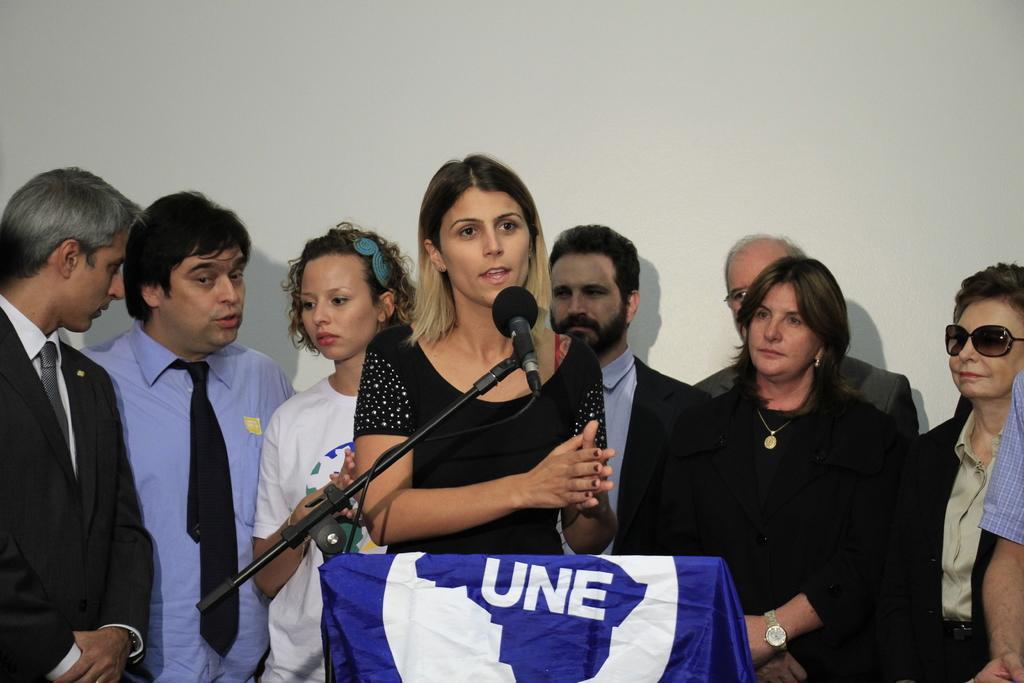In one or two sentences, can you explain what this image depicts? In this image we can see people standing and one of them is at the lectern to which mic is attached and is covered with a cloth. 